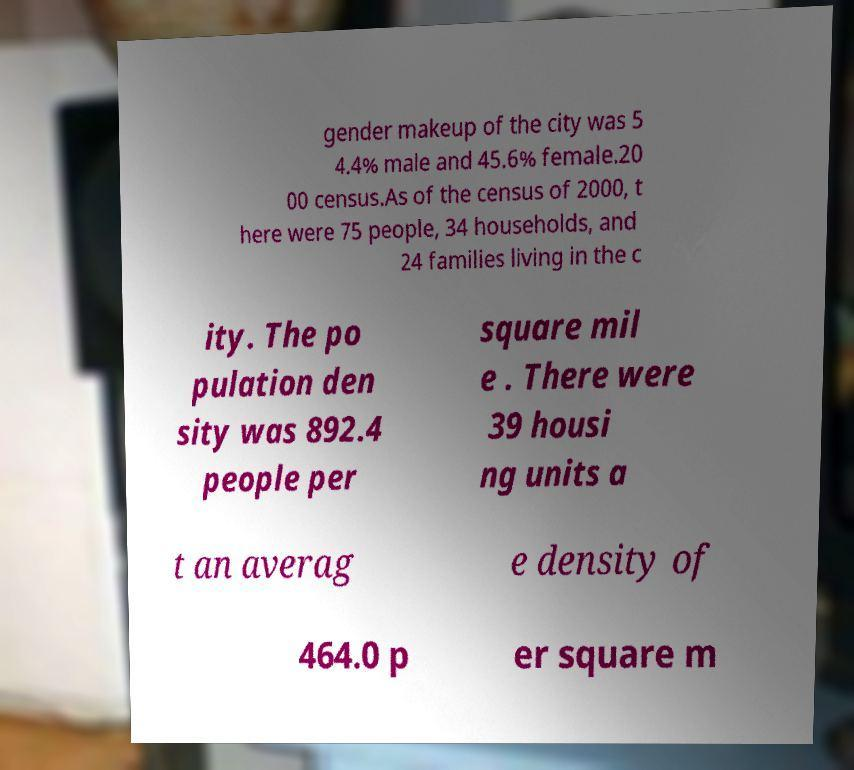Could you assist in decoding the text presented in this image and type it out clearly? gender makeup of the city was 5 4.4% male and 45.6% female.20 00 census.As of the census of 2000, t here were 75 people, 34 households, and 24 families living in the c ity. The po pulation den sity was 892.4 people per square mil e . There were 39 housi ng units a t an averag e density of 464.0 p er square m 